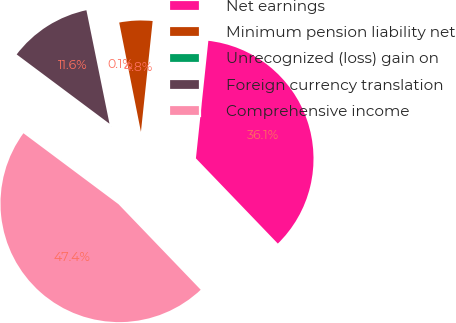<chart> <loc_0><loc_0><loc_500><loc_500><pie_chart><fcel>Net earnings<fcel>Minimum pension liability net<fcel>Unrecognized (loss) gain on<fcel>Foreign currency translation<fcel>Comprehensive income<nl><fcel>36.14%<fcel>4.8%<fcel>0.07%<fcel>11.6%<fcel>47.39%<nl></chart> 